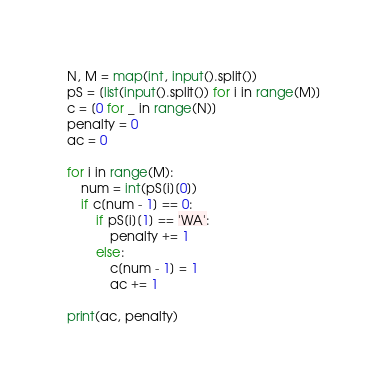<code> <loc_0><loc_0><loc_500><loc_500><_Python_>N, M = map(int, input().split())
pS = [list(input().split()) for i in range(M)]
c = [0 for _ in range(N)]
penalty = 0
ac = 0

for i in range(M):
    num = int(pS[i][0])
    if c[num - 1] == 0:
        if pS[i][1] == 'WA':
            penalty += 1
        else:
            c[num - 1] = 1
            ac += 1

print(ac, penalty)
</code> 